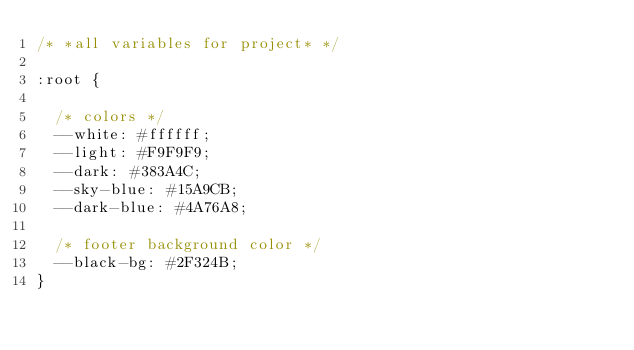<code> <loc_0><loc_0><loc_500><loc_500><_CSS_>/* *all variables for project* */

:root {

  /* colors */
  --white: #ffffff;
  --light: #F9F9F9;
  --dark: #383A4C;
  --sky-blue: #15A9CB;
  --dark-blue: #4A76A8;

  /* footer background color */
  --black-bg: #2F324B;
}
</code> 